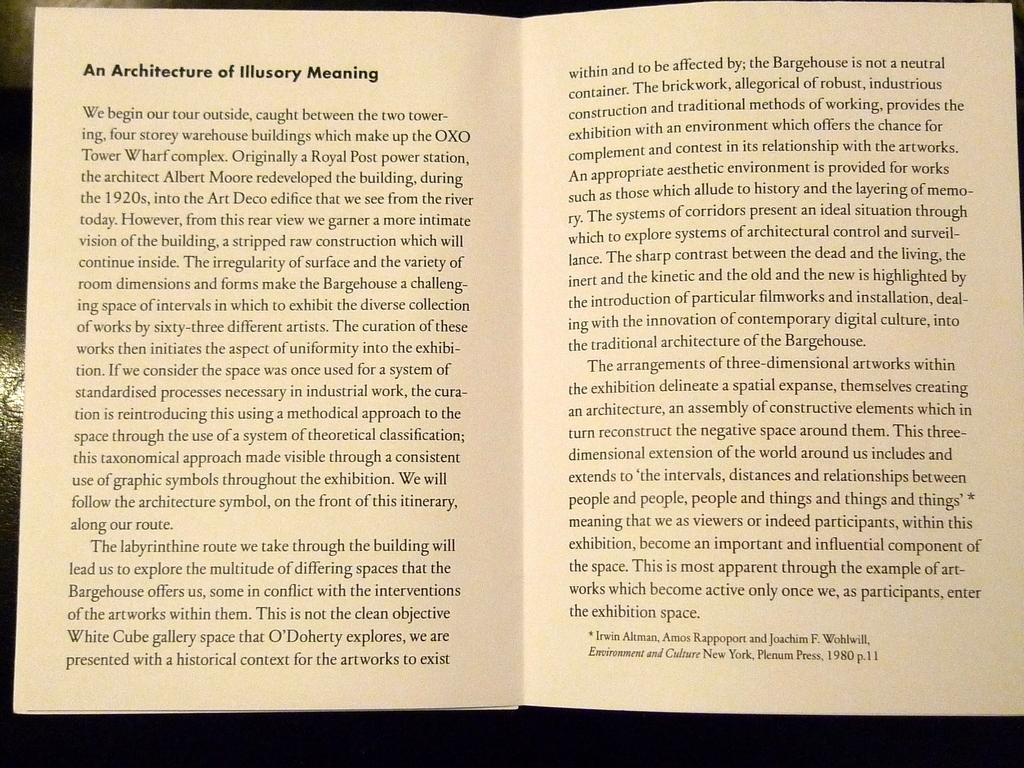Provide a one-sentence caption for the provided image. "An Architecture of Illusory Meaning" is open to a center page. 